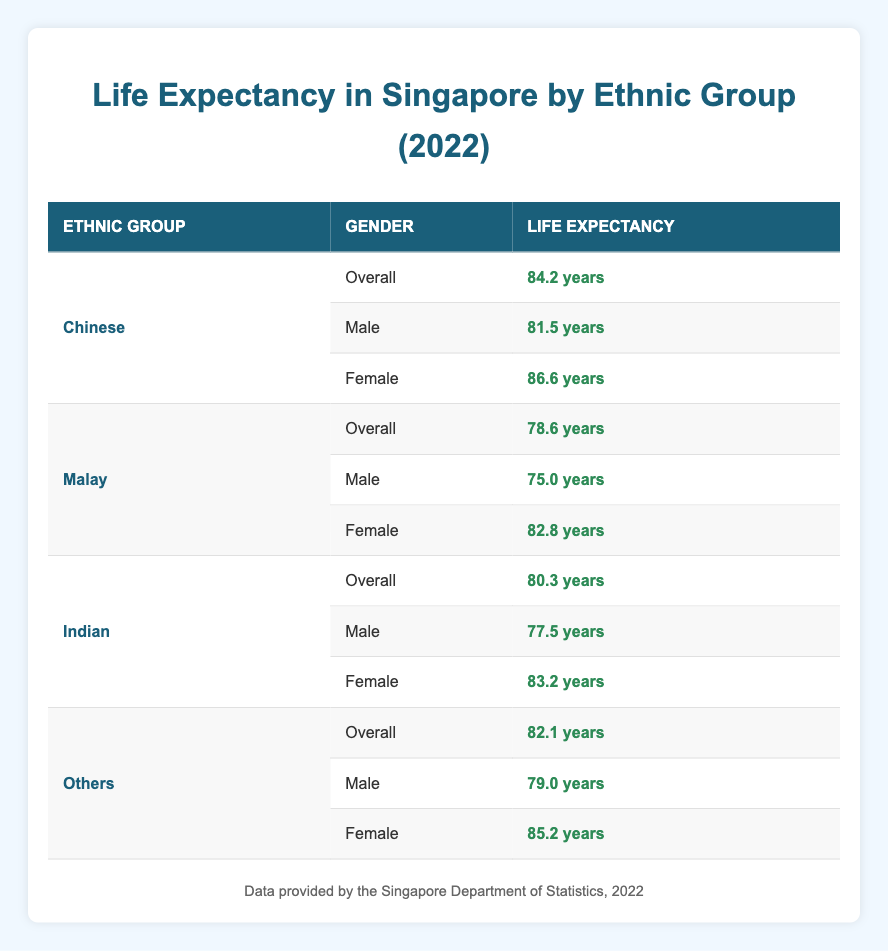What is the life expectancy of Chinese females in 2022? According to the table, the life expectancy for Chinese females in 2022 is listed directly, showing 86.6 years.
Answer: 86.6 years What is the life expectancy of Indian males in 2022? The table clearly indicates that the life expectancy for Indian males is 77.5 years.
Answer: 77.5 years What is the average life expectancy of Malay females and males combined in 2022? First, we identify the life expectancy for Malay females (82.8 years) and males (75.0 years). We then calculate the average: (82.8 + 75.0) / 2 = 78.9 years.
Answer: 78.9 years Is the overall life expectancy of the "Others" ethnic group higher than that of the Malay ethnic group in 2022? The overall life expectancy for "Others" is 82.1 years, while for Malays it is 78.6 years. Since 82.1 is greater than 78.6, the statement is true.
Answer: Yes Which ethnic group has the highest life expectancy for males in 2022? To find this, we compare the life expectancy for males across all ethnic groups: Chinese males (81.5), Malay males (75.0), Indian males (77.5), and Others (79.0). Here, Chinese males have the highest life expectancy at 81.5 years.
Answer: Chinese What is the difference in life expectancy between Chinese males and Indian females in 2022? The life expectancy for Chinese males is 81.5 years and for Indian females is 83.2 years. The difference is calculated as 83.2 - 81.5 = 1.7 years.
Answer: 1.7 years Are there more females in the ethnic groups with higher life expectancy than males in 2022? We analyze the male and female life expectancies: For Chinese, the female expectancy (86.6) is higher than male (81.5); for Malay, female (82.8) is higher than male (75.0); for Indian, female (83.2) is higher than male (77.5); and for Others, female (85.2) is higher than male (79.0). All groups show females having longer life expectancies than males, confirming the statement as true.
Answer: Yes What is the overall life expectancy for the Indian ethnic group in 2022? The overall life expectancy for the Indian ethnic group is directly listed in the table as 80.3 years.
Answer: 80.3 years 